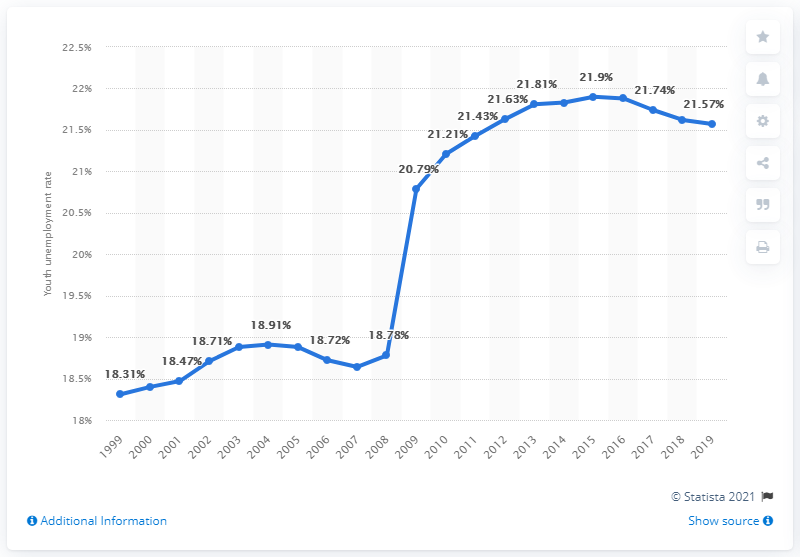Give some essential details in this illustration. In 2019, the youth unemployment rate in Djibouti was 21.57%. 